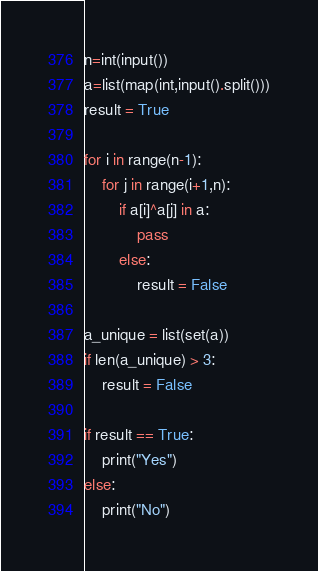<code> <loc_0><loc_0><loc_500><loc_500><_Python_>n=int(input())
a=list(map(int,input().split()))
result = True

for i in range(n-1):
    for j in range(i+1,n):
        if a[i]^a[j] in a:
            pass
        else:
            result = False

a_unique = list(set(a))
if len(a_unique) > 3:
    result = False

if result == True:
    print("Yes")
else:
    print("No")</code> 